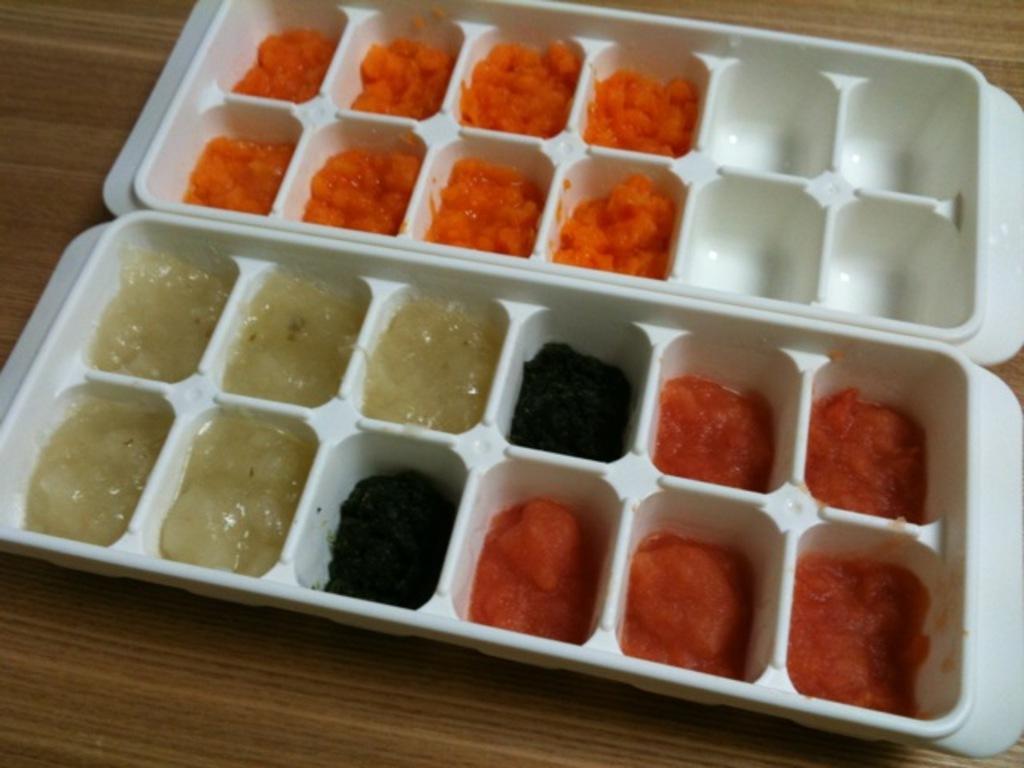Describe this image in one or two sentences. In this image we can see food item in the trays, which are on the wooden surface. 